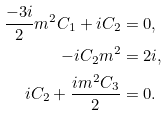Convert formula to latex. <formula><loc_0><loc_0><loc_500><loc_500>\frac { - 3 i } { 2 } m ^ { 2 } C _ { 1 } + i C _ { 2 } & = 0 , \\ - i C _ { 2 } m ^ { 2 } & = 2 i , \\ i C _ { 2 } + \frac { i m ^ { 2 } C _ { 3 } } { 2 } & = 0 .</formula> 